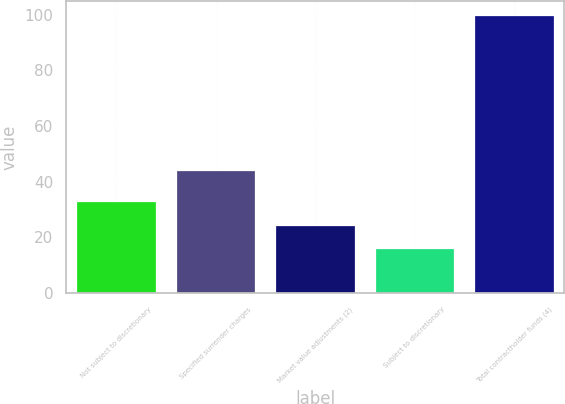Convert chart. <chart><loc_0><loc_0><loc_500><loc_500><bar_chart><fcel>Not subject to discretionary<fcel>Specified surrender charges<fcel>Market value adjustments (2)<fcel>Subject to discretionary<fcel>Total contractholder funds (4)<nl><fcel>32.96<fcel>44.1<fcel>24.58<fcel>16.2<fcel>100<nl></chart> 